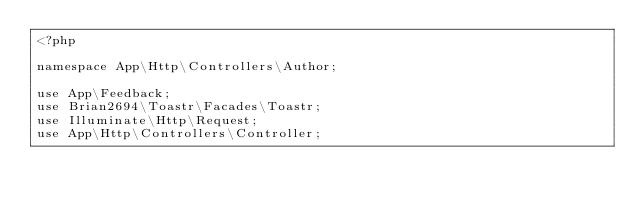Convert code to text. <code><loc_0><loc_0><loc_500><loc_500><_PHP_><?php

namespace App\Http\Controllers\Author;

use App\Feedback;
use Brian2694\Toastr\Facades\Toastr;
use Illuminate\Http\Request;
use App\Http\Controllers\Controller;</code> 